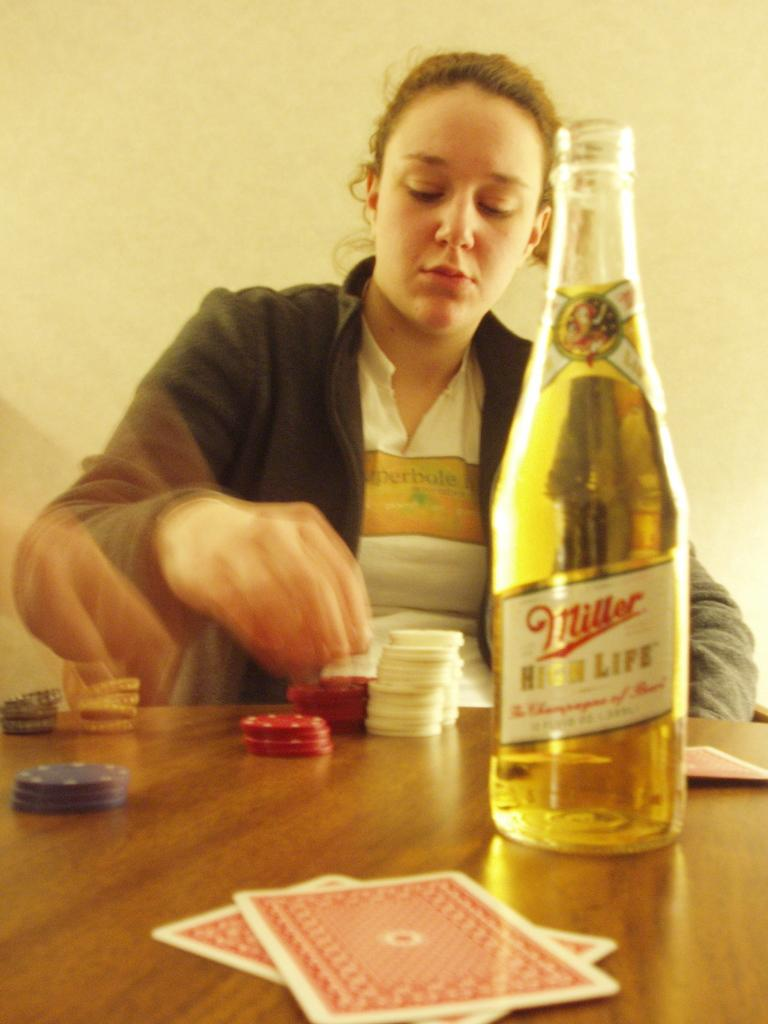<image>
Share a concise interpretation of the image provided. a bottle of miller high life standing in front of a woman on a table 